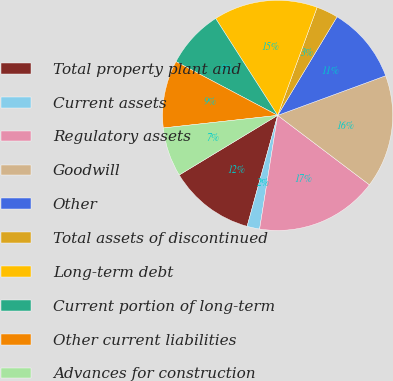Convert chart to OTSL. <chart><loc_0><loc_0><loc_500><loc_500><pie_chart><fcel>Total property plant and<fcel>Current assets<fcel>Regulatory assets<fcel>Goodwill<fcel>Other<fcel>Total assets of discontinued<fcel>Long-term debt<fcel>Current portion of long-term<fcel>Other current liabilities<fcel>Advances for construction<nl><fcel>12.06%<fcel>1.77%<fcel>17.2%<fcel>15.91%<fcel>10.77%<fcel>3.06%<fcel>14.63%<fcel>8.2%<fcel>9.49%<fcel>6.92%<nl></chart> 